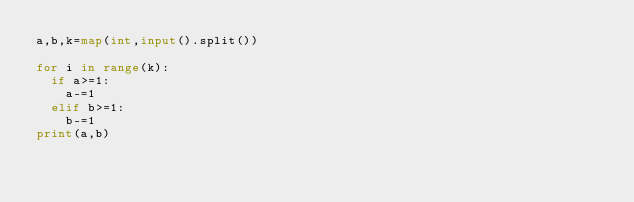<code> <loc_0><loc_0><loc_500><loc_500><_Python_>a,b,k=map(int,input().split())

for i in range(k):
  if a>=1:
    a-=1
  elif b>=1:
    b-=1
print(a,b)</code> 